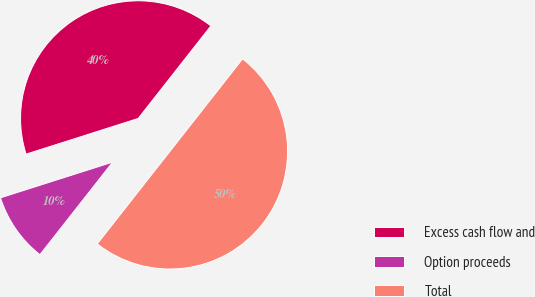Convert chart to OTSL. <chart><loc_0><loc_0><loc_500><loc_500><pie_chart><fcel>Excess cash flow and<fcel>Option proceeds<fcel>Total<nl><fcel>40.5%<fcel>9.5%<fcel>50.0%<nl></chart> 